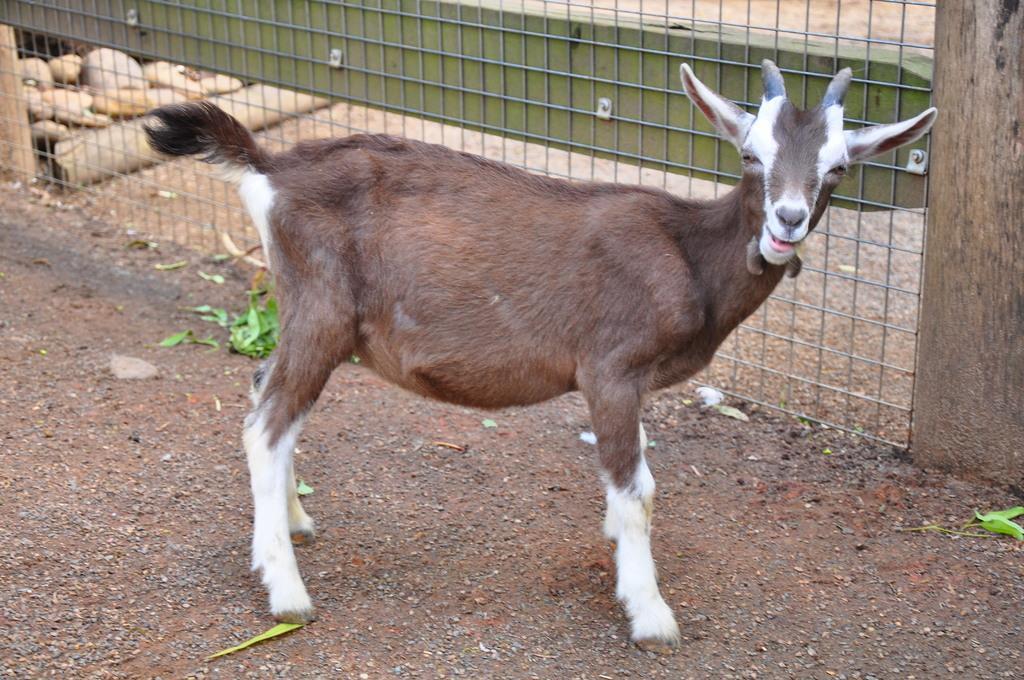How would you summarize this image in a sentence or two? In the picture there is a goat, beside the goat there is an iron fence present, there are stones. 